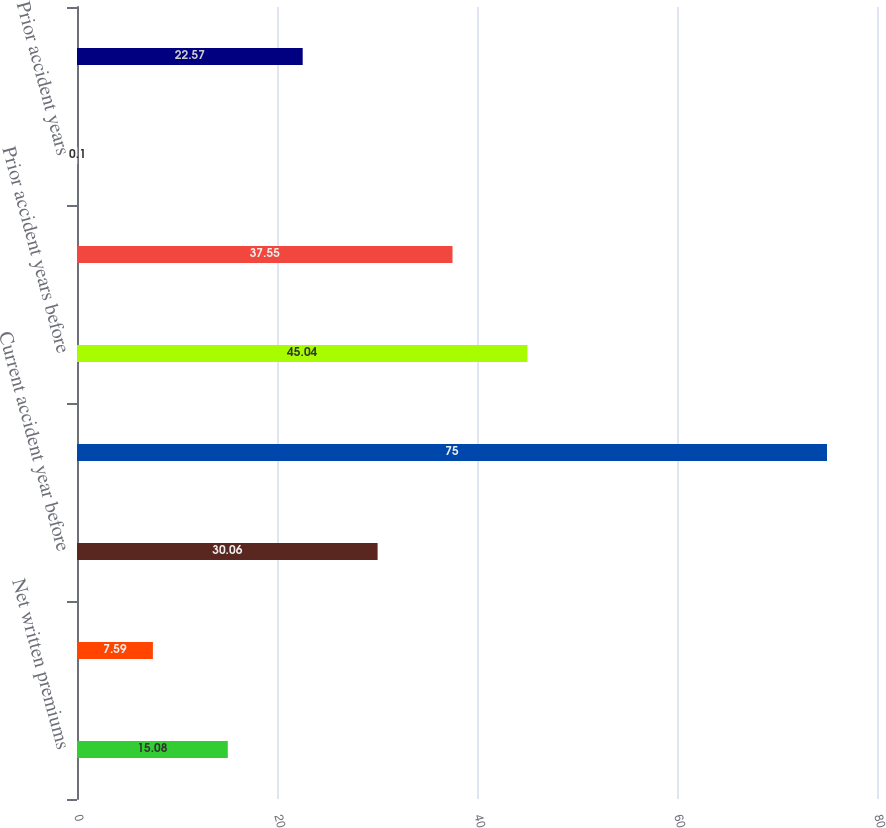<chart> <loc_0><loc_0><loc_500><loc_500><bar_chart><fcel>Net written premiums<fcel>Earned premiums<fcel>Current accident year before<fcel>Current accident year<fcel>Prior accident years before<fcel>Total loss and loss expenses<fcel>Prior accident years<fcel>Total loss and loss expense<nl><fcel>15.08<fcel>7.59<fcel>30.06<fcel>75<fcel>45.04<fcel>37.55<fcel>0.1<fcel>22.57<nl></chart> 